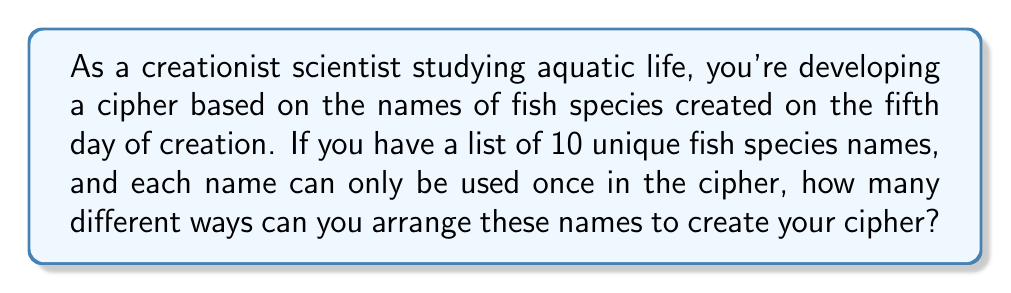Give your solution to this math problem. Let's approach this step-by-step:

1) This problem is essentially asking for the number of permutations of 10 distinct items.

2) In permutation problems, the order matters and each item can only be used once.

3) The formula for permutations of n distinct objects is:

   $$P(n) = n!$$

   Where $n!$ represents the factorial of n.

4) In this case, $n = 10$ (the number of fish species names).

5) Therefore, we need to calculate:

   $$P(10) = 10!$$

6) Let's expand this:

   $$10! = 10 \times 9 \times 8 \times 7 \times 6 \times 5 \times 4 \times 3 \times 2 \times 1$$

7) Calculating this out:

   $$10! = 3,628,800$$

Thus, there are 3,628,800 different ways to arrange the 10 fish species names in your cipher.
Answer: 3,628,800 